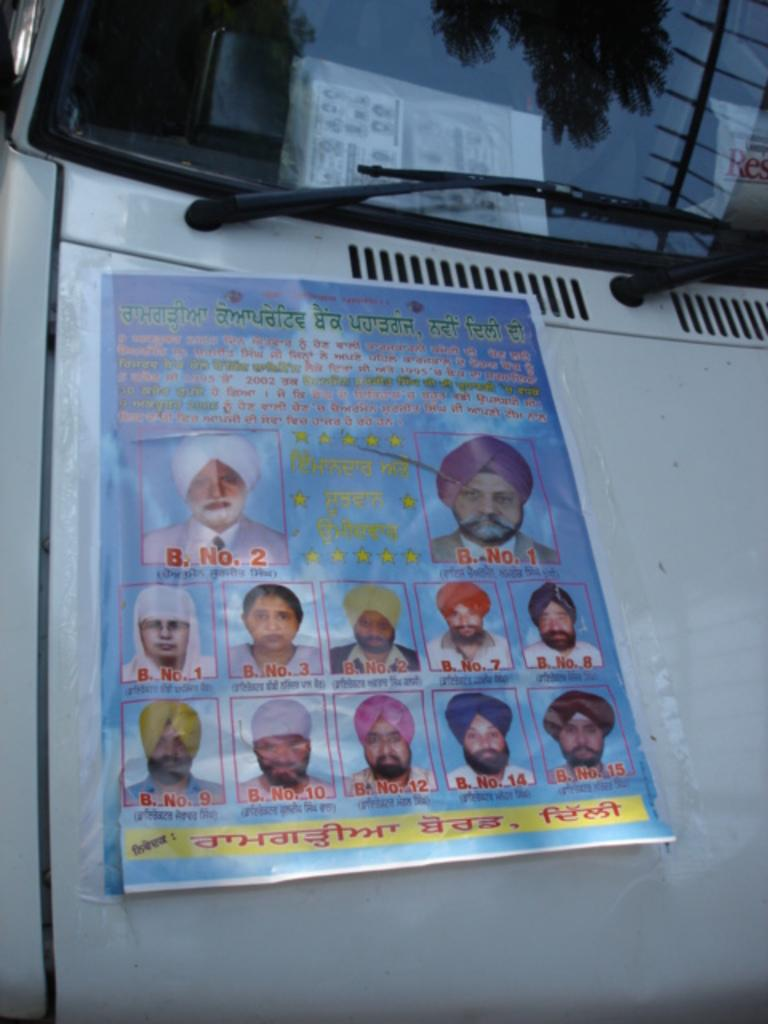What is the main subject of the image? The main subject of the image is a car. What is on the car? There is a poster on the car. What can be seen on the poster? The poster contains photographs of people. Is there any text on the poster? Yes, there is text on the poster. How many arms are visible on the roof of the car in the image? There are no arms visible on the roof of the car in the image, as the image does not depict any arms or people on the roof. 